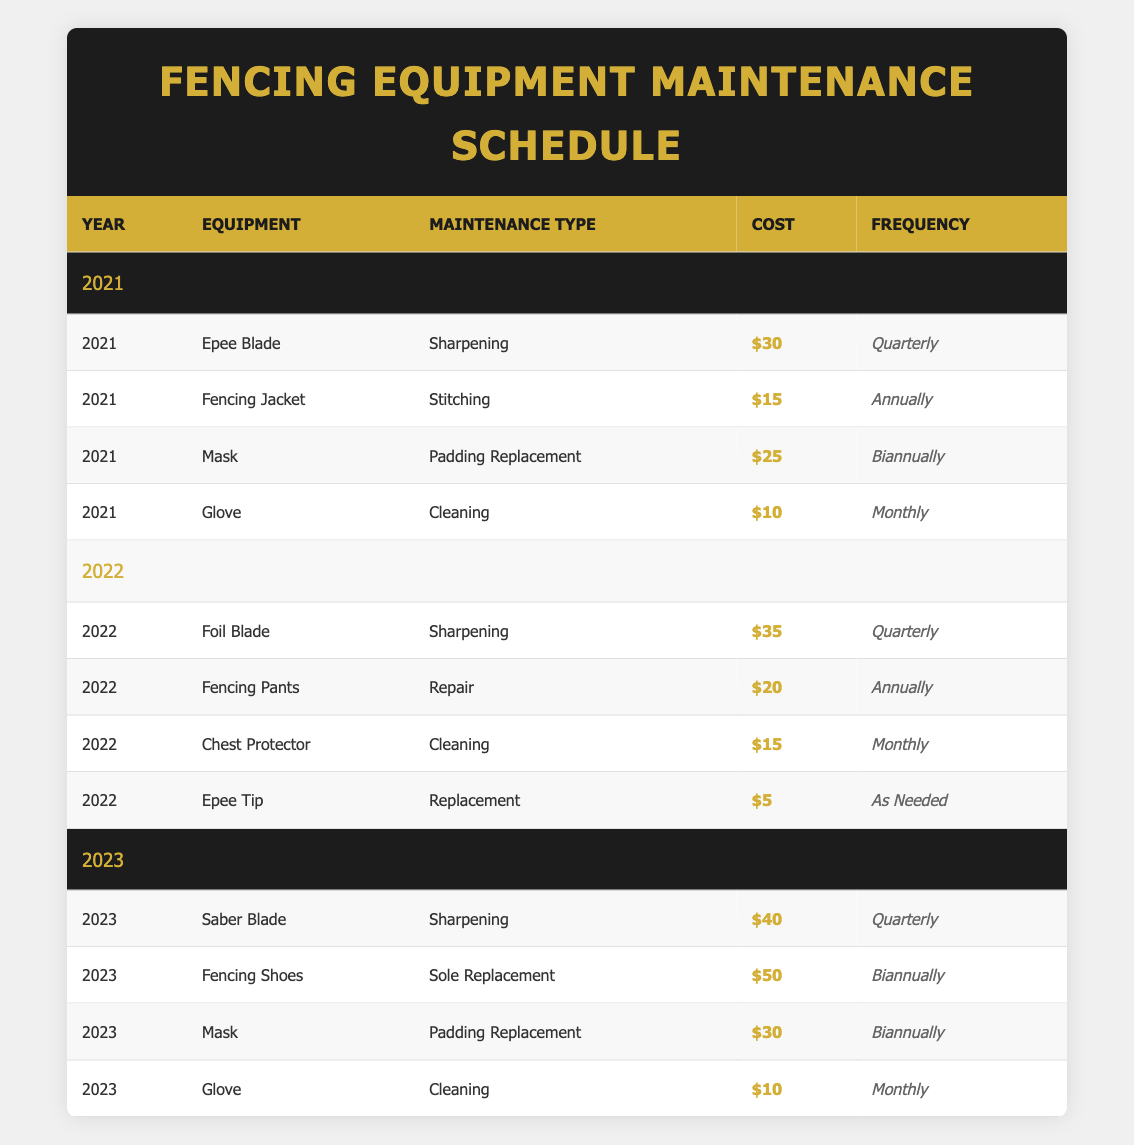What's the maintenance cost for the Fencing Jacket in 2021? The table shows that the maintenance cost for the Fencing Jacket in 2021 is $15. This value can be found directly under the relevant row for that item.
Answer: $15 How often is the Saber Blade maintained? The frequency of maintenance for the Saber Blade in 2023 is indicated as "Quarterly" in the respective row.
Answer: Quarterly Which item has the highest maintenance cost in 2023? In 2023, the item with the highest maintenance cost is the Fencing Shoes at $50, as seen in the table.
Answer: Fencing Shoes What is the total maintenance cost for all items in 2022? According to the table, the maintenance costs for items in 2022 are $35 (Foil Blade) + $20 (Fencing Pants) + $15 (Chest Protector) + $5 (Epee Tip) = $75. Therefore, the total is $75.
Answer: $75 Is it true that all gloves require cleaning monthly? According to the table, the gloves in both 2021 and 2023 require cleaning monthly, but a different type of glove is not specified for 2022. Thus, this statement is true based on the provided data.
Answer: Yes How much more does the Saber Blade cost to maintain compared to the Epee Blade in their respective years? The maintenance cost is $40 for the Saber Blade in 2023 and $30 for the Epee Blade in 2021. The difference is $40 - $30 = $10. Thus, the Saber Blade costs $10 more to maintain than the Epee Blade.
Answer: $10 What is the average maintenance cost of the items listed in 2021? The maintenance costs for 2021 are $30 (Epee Blade), $15 (Fencing Jacket), $25 (Mask), and $10 (Glove). The sum of these costs is $30 + $15 + $25 + $10 = $80. There are 4 items, so the average is $80 / 4 = $20.
Answer: $20 During which year was the chest protector maintained? The chest protector is listed with maintenance in 2022, as shown in the row with its respective costs and frequency.
Answer: 2022 Which maintenance type is most frequent for the items in the table? Upon reviewing the table, the most frequent maintenance type listed is "Monthly," as it appears for both the Glove and the Chest Protector, making it the one that occurs most frequently across the years.
Answer: Monthly 